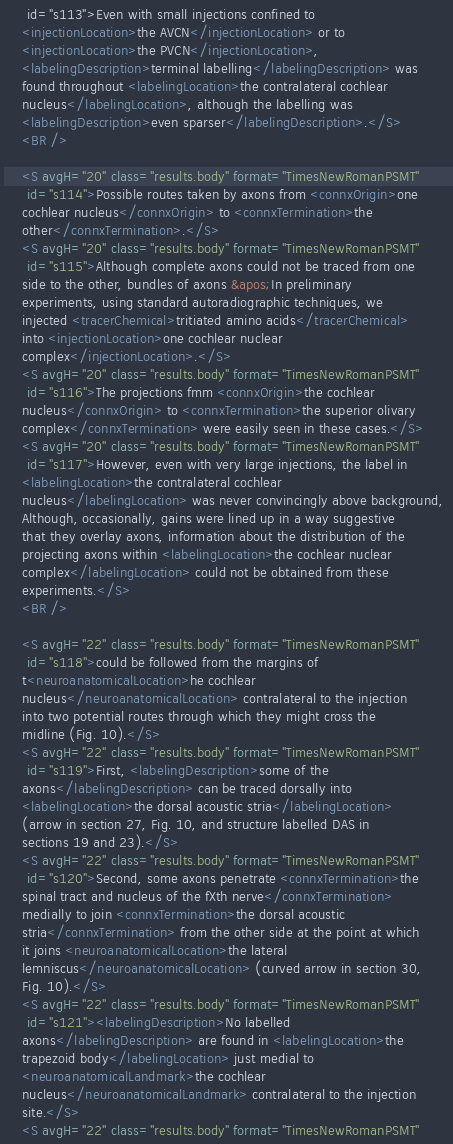<code> <loc_0><loc_0><loc_500><loc_500><_XML_>     id="s113">Even with small injections confined to 
    <injectionLocation>the AVCN</injectionLocation> or to 
    <injectionLocation>the PVCN</injectionLocation>, 
    <labelingDescription>terminal labelling</labelingDescription> was 
    found throughout <labelingLocation>the contralateral cochlear 
    nucleus</labelingLocation>, although the labelling was 
    <labelingDescription>even sparser</labelingDescription>.</S>
    <BR />

    <S avgH="20" class="results.body" format="TimesNewRomanPSMT"
     id="s114">Possible routes taken by axons from <connxOrigin>one 
    cochlear nucleus</connxOrigin> to <connxTermination>the 
    other</connxTermination>.</S>
    <S avgH="20" class="results.body" format="TimesNewRomanPSMT"
     id="s115">Although complete axons could not be traced from one 
    side to the other, bundles of axons &apos;In preliminary 
    experiments, using standard autoradiographic techniques, we 
    injected <tracerChemical>tritiated amino acids</tracerChemical> 
    into <injectionLocation>one cochlear nuclear 
    complex</injectionLocation>.</S>
    <S avgH="20" class="results.body" format="TimesNewRomanPSMT"
     id="s116">The projections fmm <connxOrigin>the cochlear 
    nucleus</connxOrigin> to <connxTermination>the superior olivary 
    complex</connxTermination> were easily seen in these cases.</S>
    <S avgH="20" class="results.body" format="TimesNewRomanPSMT"
     id="s117">However, even with very large injections, the label in 
    <labelingLocation>the contralateral cochlear 
    nucleus</labelingLocation> was never convincingly above background, 
    Although, occasionally, gains were lined up in a way suggestive 
    that they overlay axons, information about the distribution of the 
    projecting axons within <labelingLocation>the cochlear nuclear 
    complex</labelingLocation> could not be obtained from these 
    experiments.</S>
    <BR />

    <S avgH="22" class="results.body" format="TimesNewRomanPSMT"
     id="s118">could be followed from the margins of 
    t<neuroanatomicalLocation>he cochlear 
    nucleus</neuroanatomicalLocation> contralateral to the injection 
    into two potential routes through which they might cross the 
    midline (Fig. 10).</S>
    <S avgH="22" class="results.body" format="TimesNewRomanPSMT"
     id="s119">First, <labelingDescription>some of the 
    axons</labelingDescription> can be traced dorsally into 
    <labelingLocation>the dorsal acoustic stria</labelingLocation> 
    (arrow in section 27, Fig. 10, and structure labelled DAS in 
    sections 19 and 23).</S>
    <S avgH="22" class="results.body" format="TimesNewRomanPSMT"
     id="s120">Second, some axons penetrate <connxTermination>the 
    spinal tract and nucleus of the fXth nerve</connxTermination> 
    medially to join <connxTermination>the dorsal acoustic 
    stria</connxTermination> from the other side at the point at which 
    it joins <neuroanatomicalLocation>the lateral 
    lemniscus</neuroanatomicalLocation> (curved arrow in section 30, 
    Fig. 10).</S>
    <S avgH="22" class="results.body" format="TimesNewRomanPSMT"
     id="s121"><labelingDescription>No labelled 
    axons</labelingDescription> are found in <labelingLocation>the 
    trapezoid body</labelingLocation> just medial to 
    <neuroanatomicalLandmark>the cochlear 
    nucleus</neuroanatomicalLandmark> contralateral to the injection 
    site.</S>
    <S avgH="22" class="results.body" format="TimesNewRomanPSMT"</code> 